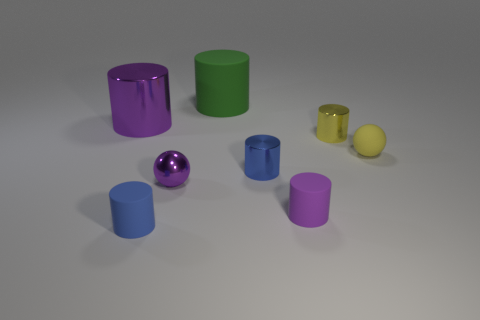What colors are represented by the objects in the image? The objects in the image showcase a variety of colors including purple, green, yellow, blue, and pink. 